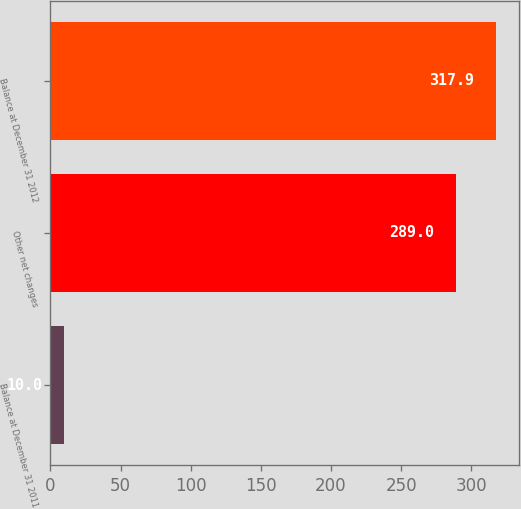Convert chart. <chart><loc_0><loc_0><loc_500><loc_500><bar_chart><fcel>Balance at December 31 2011<fcel>Other net changes<fcel>Balance at December 31 2012<nl><fcel>10<fcel>289<fcel>317.9<nl></chart> 